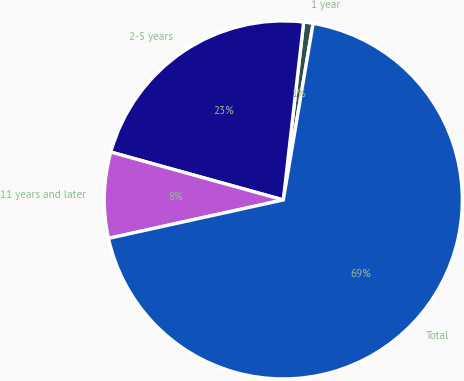Convert chart to OTSL. <chart><loc_0><loc_0><loc_500><loc_500><pie_chart><fcel>1 year<fcel>2-5 years<fcel>11 years and later<fcel>Total<nl><fcel>0.85%<fcel>22.51%<fcel>7.75%<fcel>68.9%<nl></chart> 